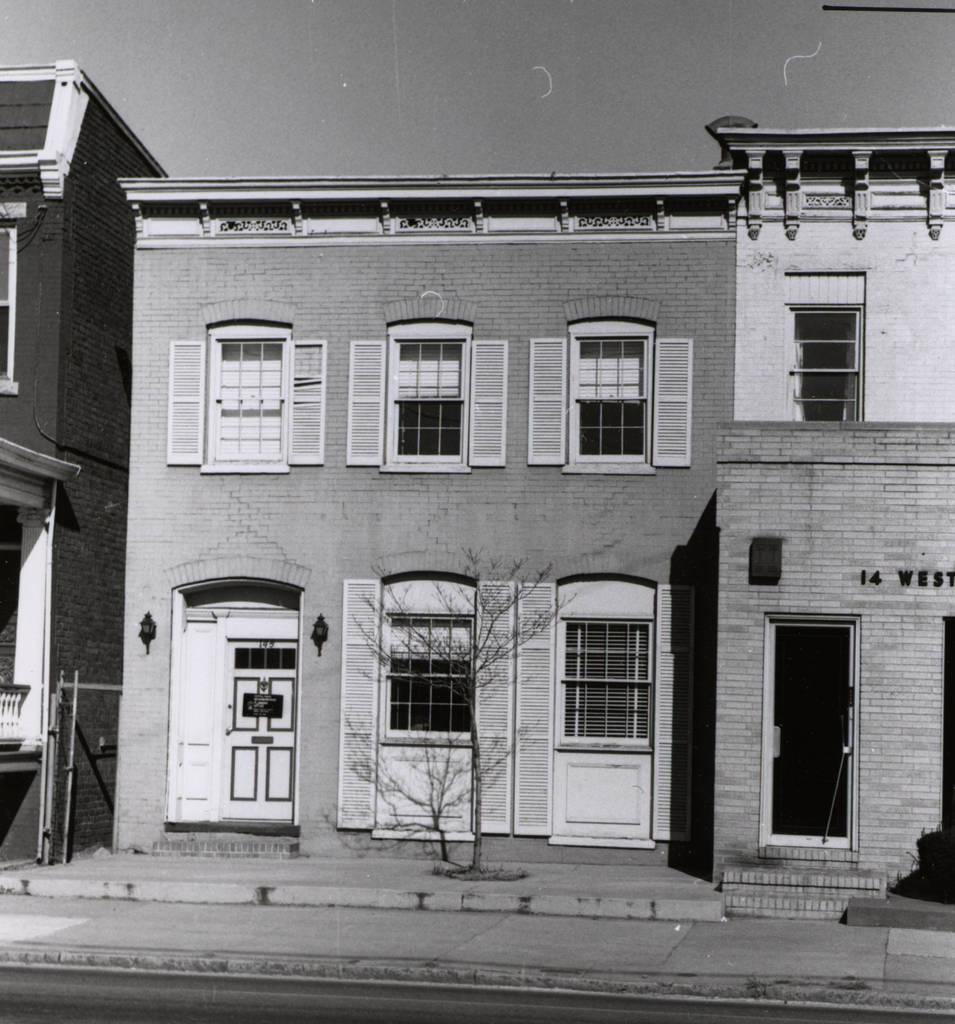How would you summarize this image in a sentence or two? In the picture we can see a house building with windows and door and near it we can see a small tree which is dried and beside it we can see another house with a door and top of it we can see a window and behind the building we can see a sky. 